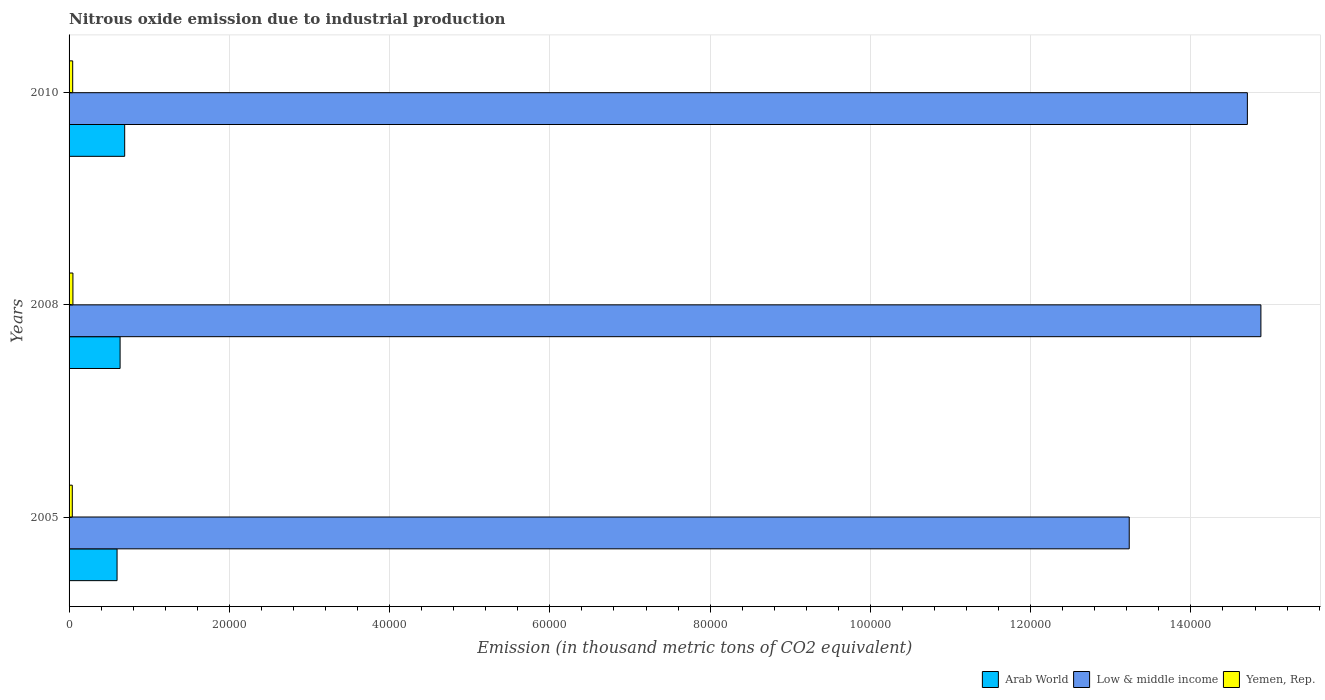How many groups of bars are there?
Your answer should be very brief. 3. Are the number of bars per tick equal to the number of legend labels?
Your answer should be compact. Yes. Are the number of bars on each tick of the Y-axis equal?
Provide a succinct answer. Yes. How many bars are there on the 2nd tick from the top?
Offer a very short reply. 3. What is the amount of nitrous oxide emitted in Yemen, Rep. in 2010?
Ensure brevity in your answer.  451.1. Across all years, what is the maximum amount of nitrous oxide emitted in Arab World?
Offer a very short reply. 6940.2. Across all years, what is the minimum amount of nitrous oxide emitted in Yemen, Rep.?
Your answer should be compact. 402.9. What is the total amount of nitrous oxide emitted in Arab World in the graph?
Ensure brevity in your answer.  1.93e+04. What is the difference between the amount of nitrous oxide emitted in Arab World in 2005 and that in 2010?
Your answer should be very brief. -951.1. What is the difference between the amount of nitrous oxide emitted in Yemen, Rep. in 2010 and the amount of nitrous oxide emitted in Arab World in 2005?
Give a very brief answer. -5538. What is the average amount of nitrous oxide emitted in Low & middle income per year?
Give a very brief answer. 1.43e+05. In the year 2010, what is the difference between the amount of nitrous oxide emitted in Yemen, Rep. and amount of nitrous oxide emitted in Low & middle income?
Ensure brevity in your answer.  -1.47e+05. What is the ratio of the amount of nitrous oxide emitted in Low & middle income in 2005 to that in 2008?
Offer a very short reply. 0.89. What is the difference between the highest and the second highest amount of nitrous oxide emitted in Yemen, Rep.?
Provide a succinct answer. 29.3. What is the difference between the highest and the lowest amount of nitrous oxide emitted in Arab World?
Give a very brief answer. 951.1. Is the sum of the amount of nitrous oxide emitted in Low & middle income in 2008 and 2010 greater than the maximum amount of nitrous oxide emitted in Arab World across all years?
Give a very brief answer. Yes. What does the 3rd bar from the top in 2010 represents?
Keep it short and to the point. Arab World. What does the 1st bar from the bottom in 2005 represents?
Offer a very short reply. Arab World. Is it the case that in every year, the sum of the amount of nitrous oxide emitted in Arab World and amount of nitrous oxide emitted in Low & middle income is greater than the amount of nitrous oxide emitted in Yemen, Rep.?
Offer a terse response. Yes. Are all the bars in the graph horizontal?
Your answer should be very brief. Yes. What is the difference between two consecutive major ticks on the X-axis?
Your response must be concise. 2.00e+04. Does the graph contain any zero values?
Make the answer very short. No. Where does the legend appear in the graph?
Offer a very short reply. Bottom right. How are the legend labels stacked?
Your answer should be very brief. Horizontal. What is the title of the graph?
Make the answer very short. Nitrous oxide emission due to industrial production. What is the label or title of the X-axis?
Provide a short and direct response. Emission (in thousand metric tons of CO2 equivalent). What is the label or title of the Y-axis?
Offer a terse response. Years. What is the Emission (in thousand metric tons of CO2 equivalent) of Arab World in 2005?
Keep it short and to the point. 5989.1. What is the Emission (in thousand metric tons of CO2 equivalent) of Low & middle income in 2005?
Provide a succinct answer. 1.32e+05. What is the Emission (in thousand metric tons of CO2 equivalent) in Yemen, Rep. in 2005?
Offer a terse response. 402.9. What is the Emission (in thousand metric tons of CO2 equivalent) of Arab World in 2008?
Offer a very short reply. 6368.1. What is the Emission (in thousand metric tons of CO2 equivalent) of Low & middle income in 2008?
Keep it short and to the point. 1.49e+05. What is the Emission (in thousand metric tons of CO2 equivalent) of Yemen, Rep. in 2008?
Give a very brief answer. 480.4. What is the Emission (in thousand metric tons of CO2 equivalent) of Arab World in 2010?
Provide a short and direct response. 6940.2. What is the Emission (in thousand metric tons of CO2 equivalent) of Low & middle income in 2010?
Your answer should be very brief. 1.47e+05. What is the Emission (in thousand metric tons of CO2 equivalent) of Yemen, Rep. in 2010?
Make the answer very short. 451.1. Across all years, what is the maximum Emission (in thousand metric tons of CO2 equivalent) in Arab World?
Your answer should be very brief. 6940.2. Across all years, what is the maximum Emission (in thousand metric tons of CO2 equivalent) in Low & middle income?
Provide a short and direct response. 1.49e+05. Across all years, what is the maximum Emission (in thousand metric tons of CO2 equivalent) of Yemen, Rep.?
Make the answer very short. 480.4. Across all years, what is the minimum Emission (in thousand metric tons of CO2 equivalent) of Arab World?
Your response must be concise. 5989.1. Across all years, what is the minimum Emission (in thousand metric tons of CO2 equivalent) of Low & middle income?
Offer a terse response. 1.32e+05. Across all years, what is the minimum Emission (in thousand metric tons of CO2 equivalent) of Yemen, Rep.?
Provide a succinct answer. 402.9. What is the total Emission (in thousand metric tons of CO2 equivalent) in Arab World in the graph?
Offer a very short reply. 1.93e+04. What is the total Emission (in thousand metric tons of CO2 equivalent) of Low & middle income in the graph?
Provide a succinct answer. 4.28e+05. What is the total Emission (in thousand metric tons of CO2 equivalent) of Yemen, Rep. in the graph?
Offer a terse response. 1334.4. What is the difference between the Emission (in thousand metric tons of CO2 equivalent) in Arab World in 2005 and that in 2008?
Your response must be concise. -379. What is the difference between the Emission (in thousand metric tons of CO2 equivalent) of Low & middle income in 2005 and that in 2008?
Your answer should be very brief. -1.64e+04. What is the difference between the Emission (in thousand metric tons of CO2 equivalent) in Yemen, Rep. in 2005 and that in 2008?
Keep it short and to the point. -77.5. What is the difference between the Emission (in thousand metric tons of CO2 equivalent) in Arab World in 2005 and that in 2010?
Your response must be concise. -951.1. What is the difference between the Emission (in thousand metric tons of CO2 equivalent) in Low & middle income in 2005 and that in 2010?
Your answer should be compact. -1.47e+04. What is the difference between the Emission (in thousand metric tons of CO2 equivalent) in Yemen, Rep. in 2005 and that in 2010?
Keep it short and to the point. -48.2. What is the difference between the Emission (in thousand metric tons of CO2 equivalent) in Arab World in 2008 and that in 2010?
Give a very brief answer. -572.1. What is the difference between the Emission (in thousand metric tons of CO2 equivalent) in Low & middle income in 2008 and that in 2010?
Your answer should be compact. 1688.4. What is the difference between the Emission (in thousand metric tons of CO2 equivalent) in Yemen, Rep. in 2008 and that in 2010?
Your answer should be compact. 29.3. What is the difference between the Emission (in thousand metric tons of CO2 equivalent) of Arab World in 2005 and the Emission (in thousand metric tons of CO2 equivalent) of Low & middle income in 2008?
Provide a succinct answer. -1.43e+05. What is the difference between the Emission (in thousand metric tons of CO2 equivalent) of Arab World in 2005 and the Emission (in thousand metric tons of CO2 equivalent) of Yemen, Rep. in 2008?
Your answer should be compact. 5508.7. What is the difference between the Emission (in thousand metric tons of CO2 equivalent) of Low & middle income in 2005 and the Emission (in thousand metric tons of CO2 equivalent) of Yemen, Rep. in 2008?
Offer a terse response. 1.32e+05. What is the difference between the Emission (in thousand metric tons of CO2 equivalent) in Arab World in 2005 and the Emission (in thousand metric tons of CO2 equivalent) in Low & middle income in 2010?
Ensure brevity in your answer.  -1.41e+05. What is the difference between the Emission (in thousand metric tons of CO2 equivalent) in Arab World in 2005 and the Emission (in thousand metric tons of CO2 equivalent) in Yemen, Rep. in 2010?
Make the answer very short. 5538. What is the difference between the Emission (in thousand metric tons of CO2 equivalent) of Low & middle income in 2005 and the Emission (in thousand metric tons of CO2 equivalent) of Yemen, Rep. in 2010?
Provide a succinct answer. 1.32e+05. What is the difference between the Emission (in thousand metric tons of CO2 equivalent) in Arab World in 2008 and the Emission (in thousand metric tons of CO2 equivalent) in Low & middle income in 2010?
Ensure brevity in your answer.  -1.41e+05. What is the difference between the Emission (in thousand metric tons of CO2 equivalent) of Arab World in 2008 and the Emission (in thousand metric tons of CO2 equivalent) of Yemen, Rep. in 2010?
Make the answer very short. 5917. What is the difference between the Emission (in thousand metric tons of CO2 equivalent) in Low & middle income in 2008 and the Emission (in thousand metric tons of CO2 equivalent) in Yemen, Rep. in 2010?
Your answer should be very brief. 1.48e+05. What is the average Emission (in thousand metric tons of CO2 equivalent) in Arab World per year?
Keep it short and to the point. 6432.47. What is the average Emission (in thousand metric tons of CO2 equivalent) of Low & middle income per year?
Ensure brevity in your answer.  1.43e+05. What is the average Emission (in thousand metric tons of CO2 equivalent) of Yemen, Rep. per year?
Your answer should be compact. 444.8. In the year 2005, what is the difference between the Emission (in thousand metric tons of CO2 equivalent) of Arab World and Emission (in thousand metric tons of CO2 equivalent) of Low & middle income?
Provide a succinct answer. -1.26e+05. In the year 2005, what is the difference between the Emission (in thousand metric tons of CO2 equivalent) in Arab World and Emission (in thousand metric tons of CO2 equivalent) in Yemen, Rep.?
Offer a terse response. 5586.2. In the year 2005, what is the difference between the Emission (in thousand metric tons of CO2 equivalent) in Low & middle income and Emission (in thousand metric tons of CO2 equivalent) in Yemen, Rep.?
Offer a terse response. 1.32e+05. In the year 2008, what is the difference between the Emission (in thousand metric tons of CO2 equivalent) in Arab World and Emission (in thousand metric tons of CO2 equivalent) in Low & middle income?
Your response must be concise. -1.42e+05. In the year 2008, what is the difference between the Emission (in thousand metric tons of CO2 equivalent) in Arab World and Emission (in thousand metric tons of CO2 equivalent) in Yemen, Rep.?
Your response must be concise. 5887.7. In the year 2008, what is the difference between the Emission (in thousand metric tons of CO2 equivalent) in Low & middle income and Emission (in thousand metric tons of CO2 equivalent) in Yemen, Rep.?
Offer a very short reply. 1.48e+05. In the year 2010, what is the difference between the Emission (in thousand metric tons of CO2 equivalent) of Arab World and Emission (in thousand metric tons of CO2 equivalent) of Low & middle income?
Offer a terse response. -1.40e+05. In the year 2010, what is the difference between the Emission (in thousand metric tons of CO2 equivalent) in Arab World and Emission (in thousand metric tons of CO2 equivalent) in Yemen, Rep.?
Offer a very short reply. 6489.1. In the year 2010, what is the difference between the Emission (in thousand metric tons of CO2 equivalent) in Low & middle income and Emission (in thousand metric tons of CO2 equivalent) in Yemen, Rep.?
Your answer should be very brief. 1.47e+05. What is the ratio of the Emission (in thousand metric tons of CO2 equivalent) in Arab World in 2005 to that in 2008?
Your answer should be compact. 0.94. What is the ratio of the Emission (in thousand metric tons of CO2 equivalent) of Low & middle income in 2005 to that in 2008?
Ensure brevity in your answer.  0.89. What is the ratio of the Emission (in thousand metric tons of CO2 equivalent) of Yemen, Rep. in 2005 to that in 2008?
Your response must be concise. 0.84. What is the ratio of the Emission (in thousand metric tons of CO2 equivalent) in Arab World in 2005 to that in 2010?
Your response must be concise. 0.86. What is the ratio of the Emission (in thousand metric tons of CO2 equivalent) in Low & middle income in 2005 to that in 2010?
Offer a terse response. 0.9. What is the ratio of the Emission (in thousand metric tons of CO2 equivalent) in Yemen, Rep. in 2005 to that in 2010?
Give a very brief answer. 0.89. What is the ratio of the Emission (in thousand metric tons of CO2 equivalent) of Arab World in 2008 to that in 2010?
Provide a short and direct response. 0.92. What is the ratio of the Emission (in thousand metric tons of CO2 equivalent) in Low & middle income in 2008 to that in 2010?
Offer a terse response. 1.01. What is the ratio of the Emission (in thousand metric tons of CO2 equivalent) in Yemen, Rep. in 2008 to that in 2010?
Ensure brevity in your answer.  1.06. What is the difference between the highest and the second highest Emission (in thousand metric tons of CO2 equivalent) of Arab World?
Provide a short and direct response. 572.1. What is the difference between the highest and the second highest Emission (in thousand metric tons of CO2 equivalent) of Low & middle income?
Ensure brevity in your answer.  1688.4. What is the difference between the highest and the second highest Emission (in thousand metric tons of CO2 equivalent) of Yemen, Rep.?
Provide a short and direct response. 29.3. What is the difference between the highest and the lowest Emission (in thousand metric tons of CO2 equivalent) of Arab World?
Your answer should be very brief. 951.1. What is the difference between the highest and the lowest Emission (in thousand metric tons of CO2 equivalent) of Low & middle income?
Keep it short and to the point. 1.64e+04. What is the difference between the highest and the lowest Emission (in thousand metric tons of CO2 equivalent) of Yemen, Rep.?
Give a very brief answer. 77.5. 